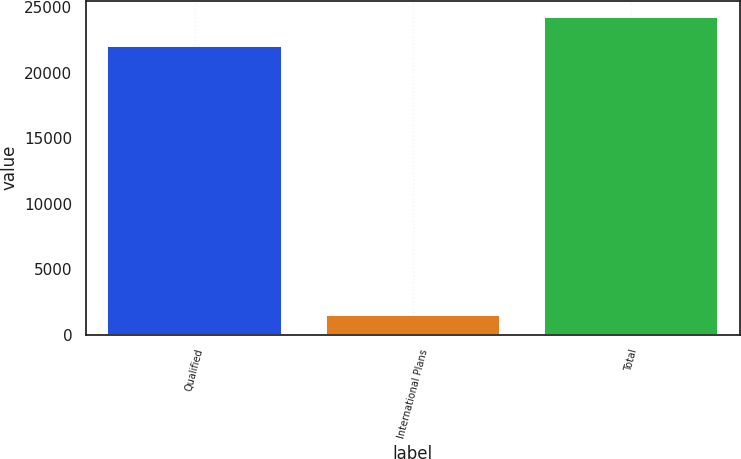<chart> <loc_0><loc_0><loc_500><loc_500><bar_chart><fcel>Qualified<fcel>International Plans<fcel>Total<nl><fcel>22057<fcel>1509<fcel>24262.7<nl></chart> 